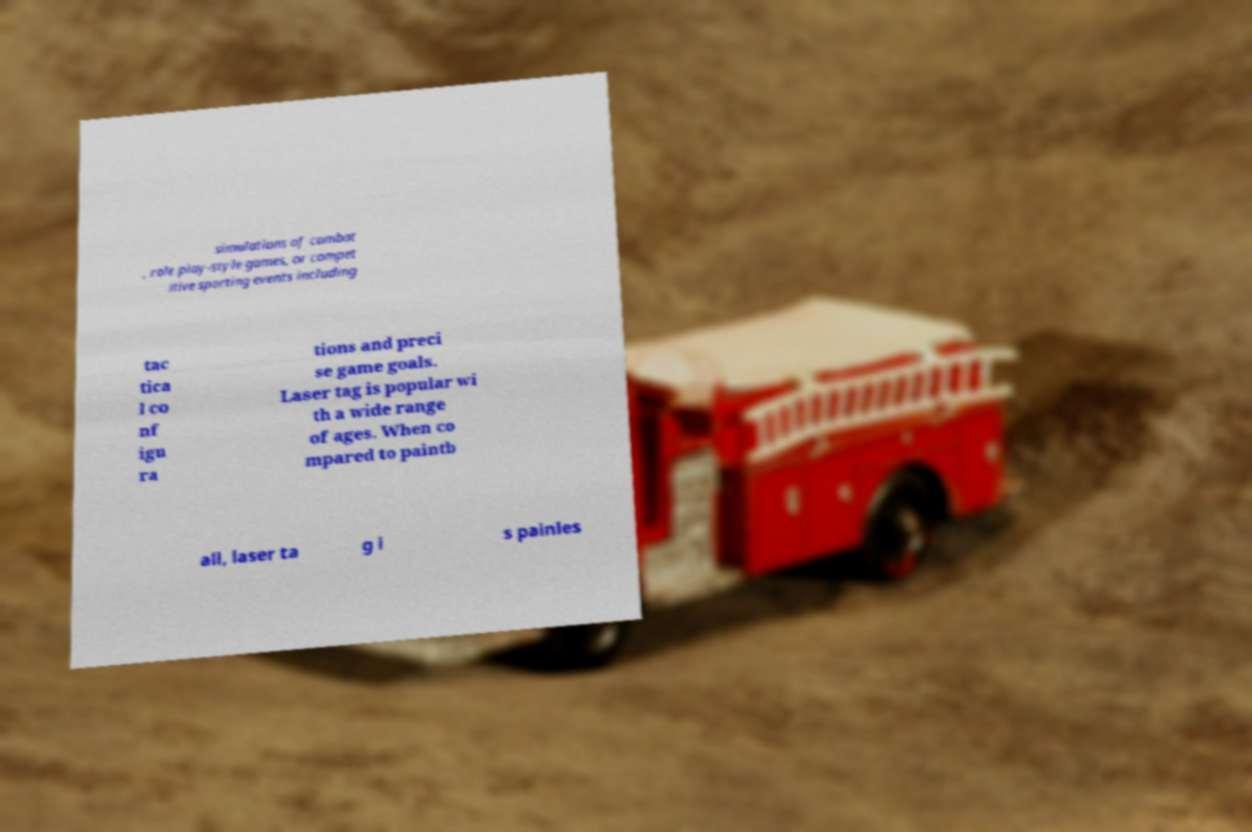I need the written content from this picture converted into text. Can you do that? simulations of combat , role play-style games, or compet itive sporting events including tac tica l co nf igu ra tions and preci se game goals. Laser tag is popular wi th a wide range of ages. When co mpared to paintb all, laser ta g i s painles 